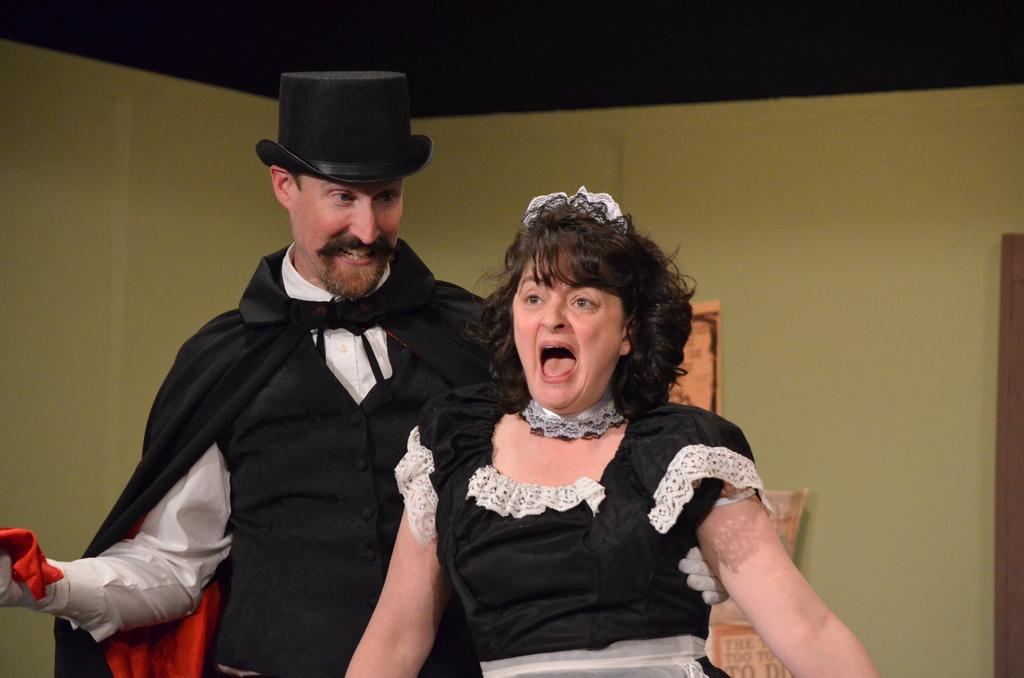What are the people in the image wearing? The people in the image are wearing costumes. Can you describe any specific accessory worn by one of the people? One of the people is wearing a hat. What can be seen in the background of the image? There is a wall and papers visible in the background of the image. What language is spoken by the people in the image? The image does not provide any information about the language spoken by the people. What type of space is depicted in the image? The image does not depict any space; it features people wearing costumes and a background with a wall and papers. 